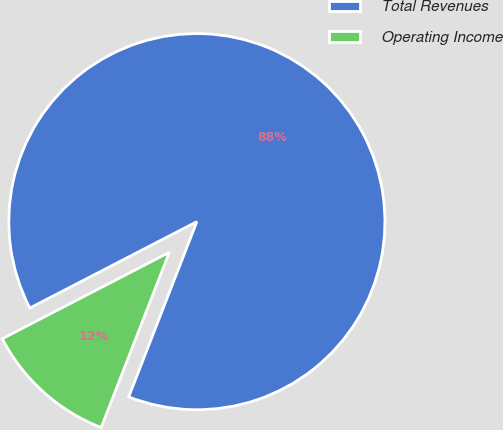Convert chart. <chart><loc_0><loc_0><loc_500><loc_500><pie_chart><fcel>Total Revenues<fcel>Operating Income<nl><fcel>88.5%<fcel>11.5%<nl></chart> 